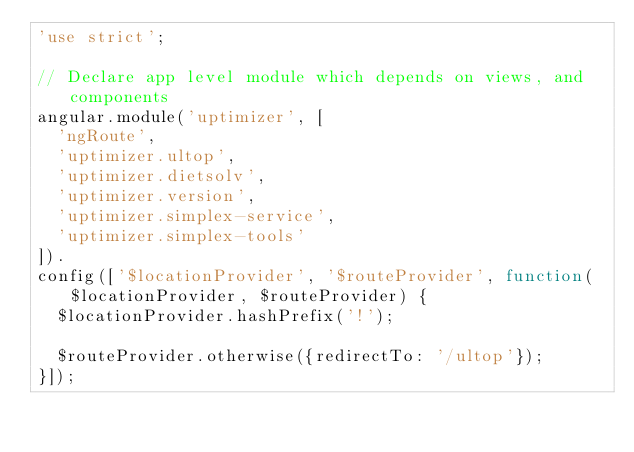<code> <loc_0><loc_0><loc_500><loc_500><_JavaScript_>'use strict';

// Declare app level module which depends on views, and components
angular.module('uptimizer', [
  'ngRoute',
  'uptimizer.ultop',
  'uptimizer.dietsolv',
  'uptimizer.version',
  'uptimizer.simplex-service',
  'uptimizer.simplex-tools'
]).
config(['$locationProvider', '$routeProvider', function($locationProvider, $routeProvider) {
  $locationProvider.hashPrefix('!');

  $routeProvider.otherwise({redirectTo: '/ultop'});
}]);
</code> 